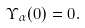Convert formula to latex. <formula><loc_0><loc_0><loc_500><loc_500>\Upsilon _ { \alpha } ( 0 ) = 0 .</formula> 